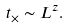<formula> <loc_0><loc_0><loc_500><loc_500>t _ { \times } \sim L ^ { z } .</formula> 